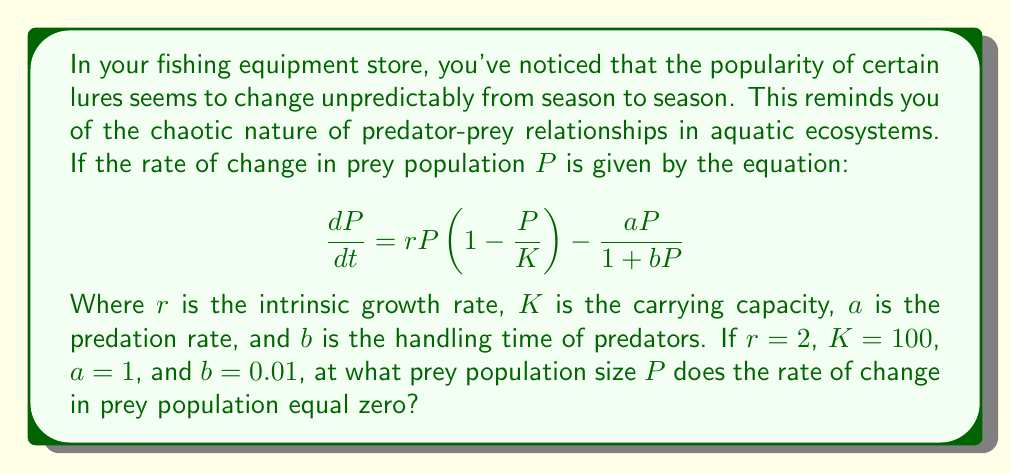Show me your answer to this math problem. Let's approach this step-by-step:

1) We need to find $P$ when $\frac{dP}{dt} = 0$. So, we set up the equation:

   $$0 = rP(1-\frac{P}{K}) - \frac{aP}{1+bP}$$

2) Now, let's substitute the given values:
   $r=2$, $K=100$, $a=1$, $b=0.01$

   $$0 = 2P(1-\frac{P}{100}) - \frac{P}{1+0.01P}$$

3) Simplify the first term:

   $$0 = 2P - \frac{2P^2}{100} - \frac{P}{1+0.01P}$$

4) Multiply both sides by $(1+0.01P)$ to eliminate the fraction:

   $$0 = (2P - \frac{2P^2}{100})(1+0.01P) - P$$

5) Expand the brackets:

   $$0 = 2P + 0.02P^2 - \frac{2P^2}{100} - \frac{2P^3}{10000} - P$$

6) Simplify:

   $$0 = P + 0.02P^2 - 0.02P^2 - 0.0002P^3$$

7) Combine like terms:

   $$0 = P - 0.0002P^3$$

8) Factor out $P$:

   $$0 = P(1 - 0.0002P^2)$$

9) For this to be true, either $P=0$ or $(1 - 0.0002P^2)=0$

10) Solving $(1 - 0.0002P^2)=0$:

    $$0.0002P^2 = 1$$
    $$P^2 = 5000$$
    $$P = \sqrt{5000} \approx 70.71$$

Therefore, the non-zero solution is approximately 70.71.
Answer: $P \approx 70.71$ 